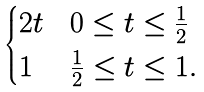Convert formula to latex. <formula><loc_0><loc_0><loc_500><loc_500>\begin{cases} 2 t & 0 \leq t \leq \frac { 1 } { 2 } \\ 1 & \frac { 1 } { 2 } \leq t \leq 1 . \end{cases}</formula> 